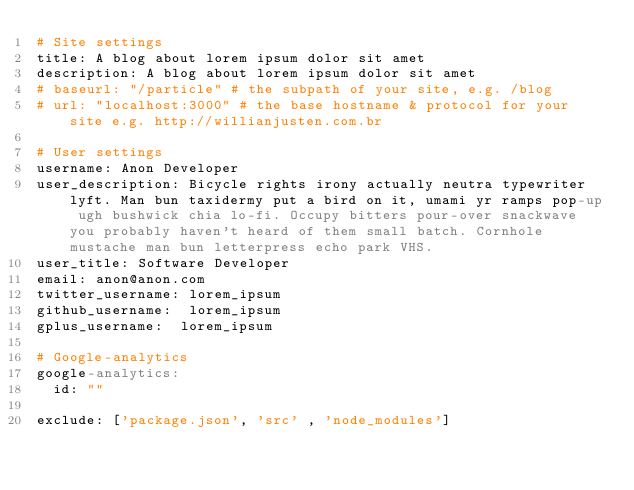Convert code to text. <code><loc_0><loc_0><loc_500><loc_500><_YAML_># Site settings
title: A blog about lorem ipsum dolor sit amet
description: A blog about lorem ipsum dolor sit amet
# baseurl: "/particle" # the subpath of your site, e.g. /blog
# url: "localhost:3000" # the base hostname & protocol for your site e.g. http://willianjusten.com.br

# User settings
username: Anon Developer
user_description: Bicycle rights irony actually neutra typewriter lyft. Man bun taxidermy put a bird on it, umami yr ramps pop-up ugh bushwick chia lo-fi. Occupy bitters pour-over snackwave you probably haven't heard of them small batch. Cornhole mustache man bun letterpress echo park VHS.
user_title: Software Developer
email: anon@anon.com
twitter_username: lorem_ipsum
github_username:  lorem_ipsum
gplus_username:  lorem_ipsum

# Google-analytics
google-analytics:
  id: ""

exclude: ['package.json', 'src' , 'node_modules']
</code> 